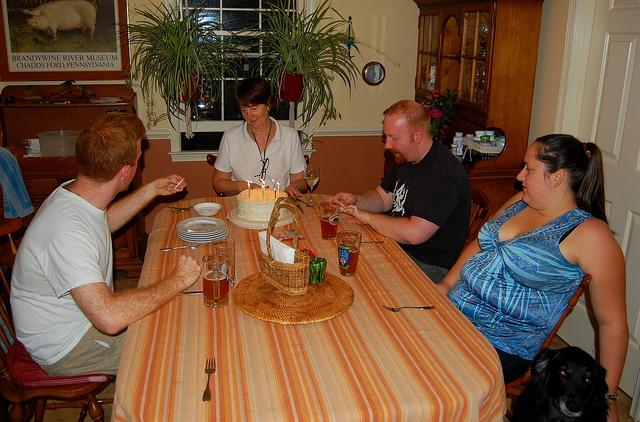Is this a family?
Short answer required. Yes. Are they celebrating a birthday?
Answer briefly. Yes. Are they in a restaurant?
Be succinct. No. 